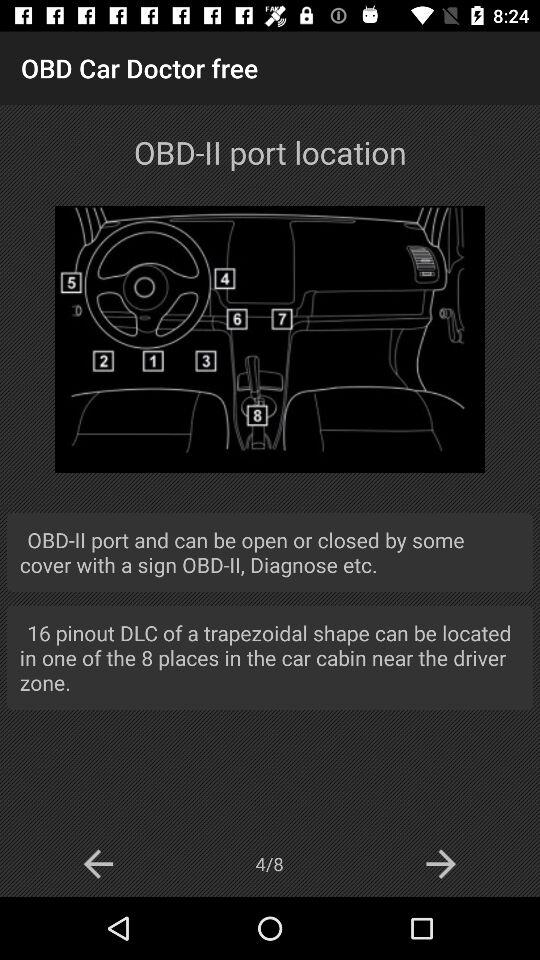How many pages in total are there? There are 8 pages in total. 